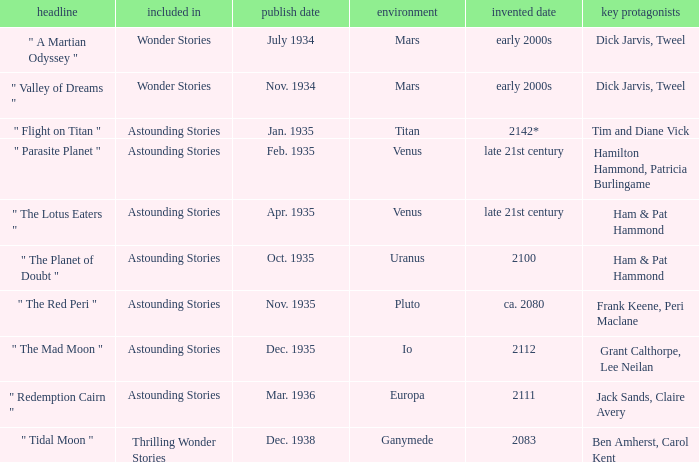Name the publication date when the fictional date is 2112 Dec. 1935. 